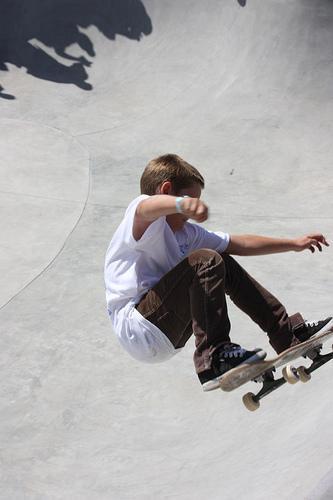How many chairs are visible?
Give a very brief answer. 0. 